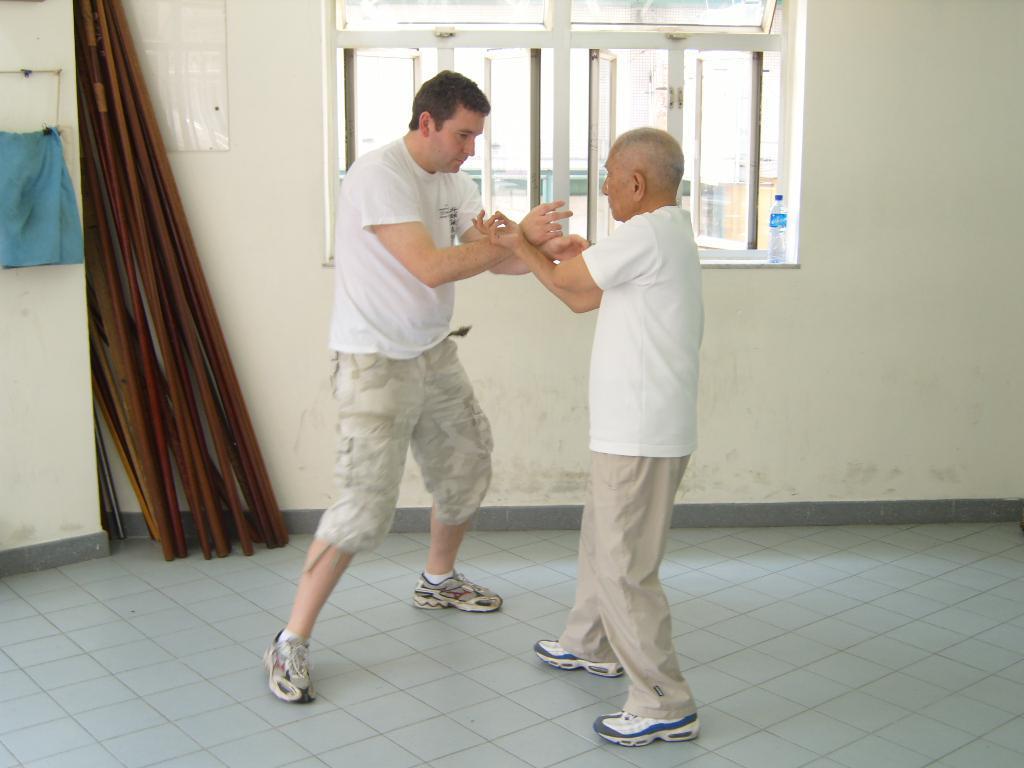Describe this image in one or two sentences. In the center of the image, we can see two people fighting and in the background, there are rods and we can see a poster on the wall and there is a cloth and there are windows and a bottle. At the bottom, there is a floor. 